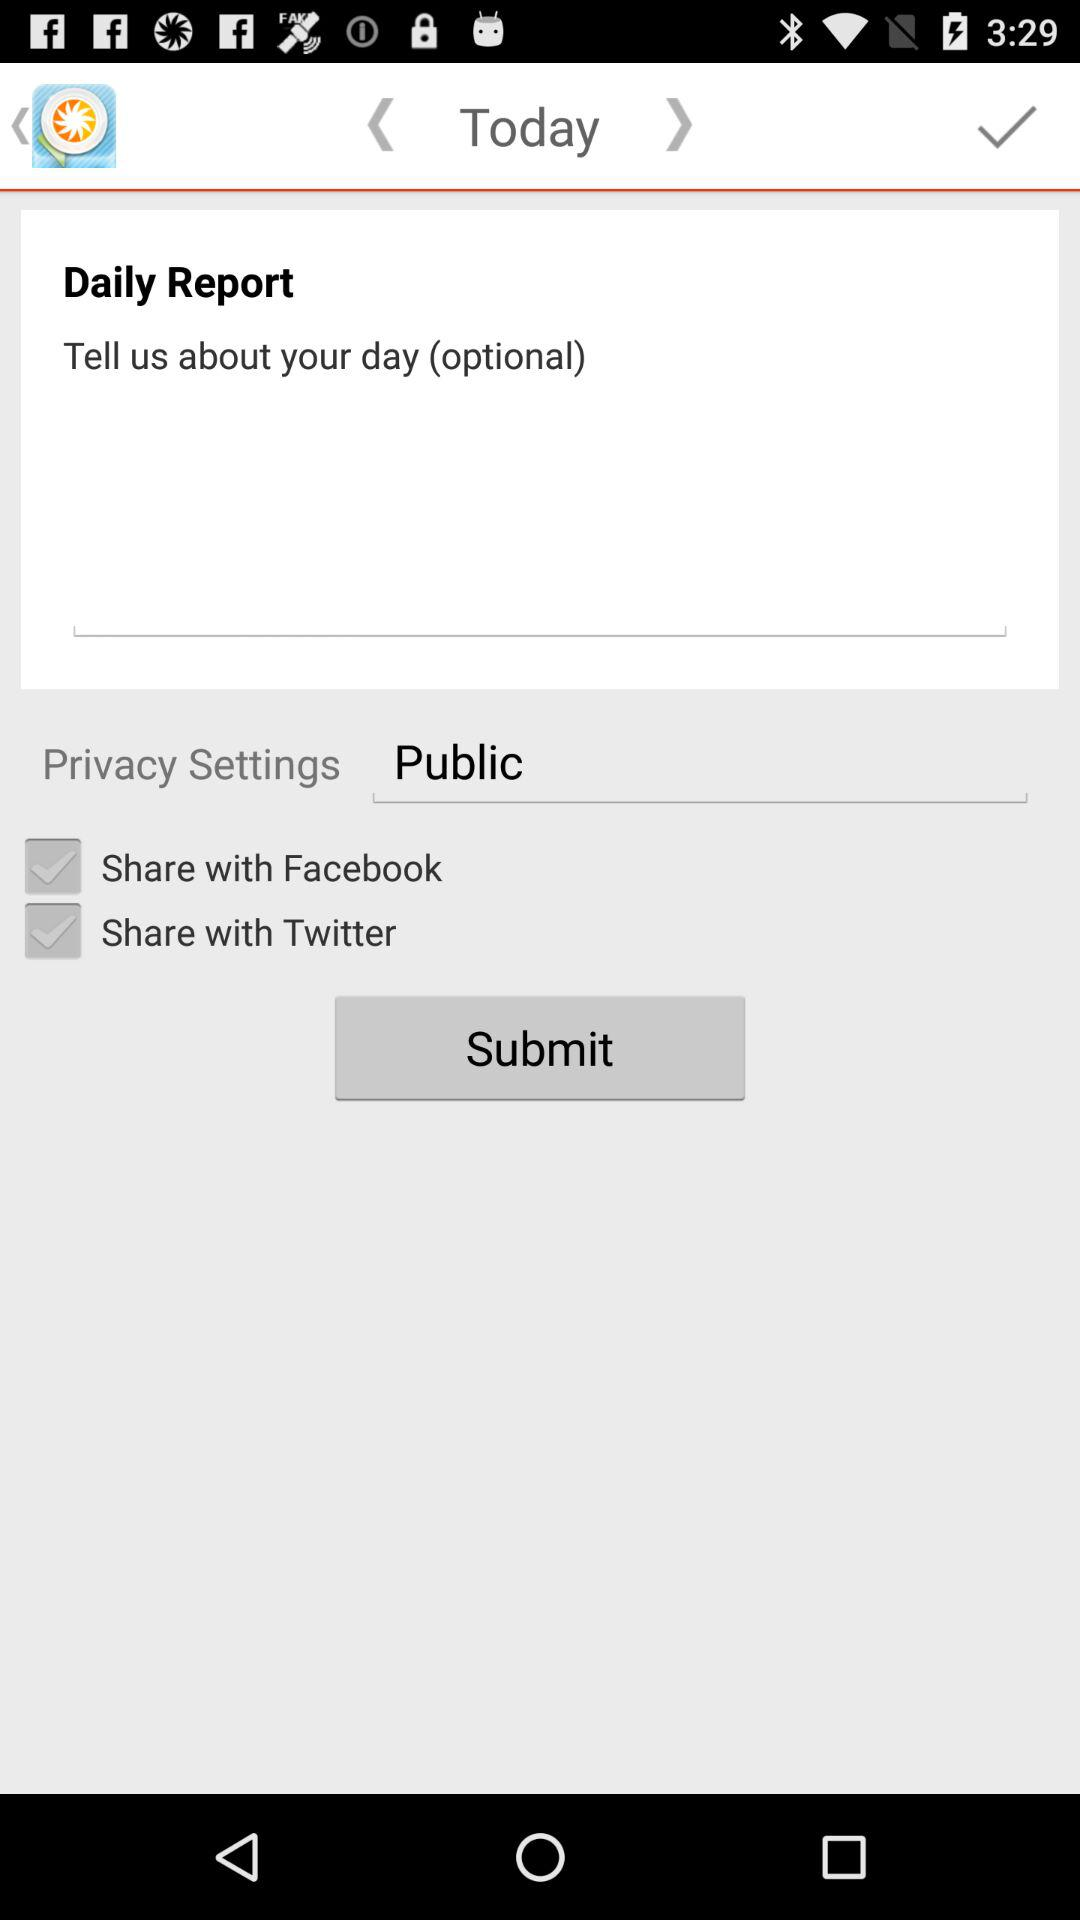What is the daily report privacy setting? The daily report privacy setting is Public. 